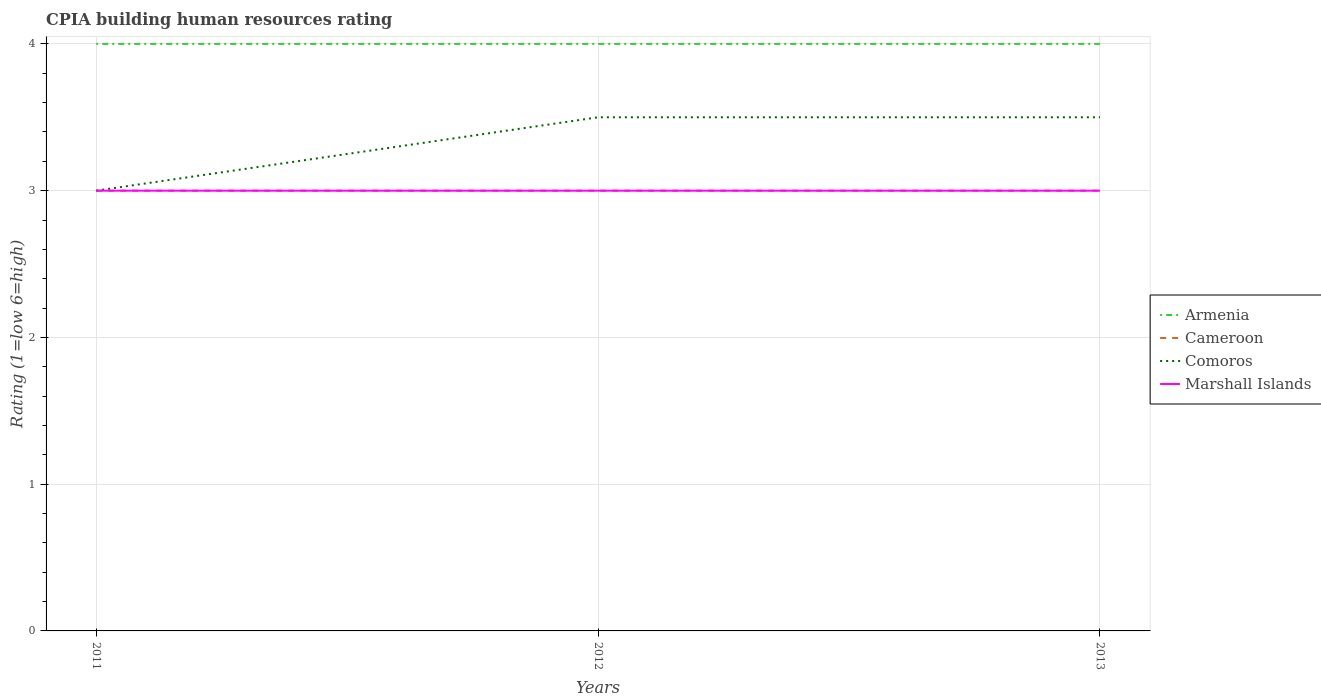Is the number of lines equal to the number of legend labels?
Your response must be concise. Yes. Across all years, what is the maximum CPIA rating in Marshall Islands?
Your answer should be very brief. 3. In which year was the CPIA rating in Comoros maximum?
Provide a short and direct response. 2011. What is the difference between the highest and the lowest CPIA rating in Comoros?
Provide a succinct answer. 2. Is the CPIA rating in Comoros strictly greater than the CPIA rating in Cameroon over the years?
Your answer should be very brief. No. Does the graph contain any zero values?
Offer a terse response. No. Does the graph contain grids?
Provide a succinct answer. Yes. Where does the legend appear in the graph?
Your answer should be very brief. Center right. How are the legend labels stacked?
Make the answer very short. Vertical. What is the title of the graph?
Make the answer very short. CPIA building human resources rating. What is the label or title of the X-axis?
Give a very brief answer. Years. What is the label or title of the Y-axis?
Provide a succinct answer. Rating (1=low 6=high). What is the Rating (1=low 6=high) of Comoros in 2011?
Make the answer very short. 3. What is the Rating (1=low 6=high) in Marshall Islands in 2011?
Your answer should be compact. 3. What is the Rating (1=low 6=high) in Armenia in 2012?
Offer a terse response. 4. What is the Rating (1=low 6=high) in Cameroon in 2012?
Give a very brief answer. 3. Across all years, what is the minimum Rating (1=low 6=high) in Armenia?
Offer a very short reply. 4. What is the total Rating (1=low 6=high) in Armenia in the graph?
Provide a short and direct response. 12. What is the total Rating (1=low 6=high) in Cameroon in the graph?
Provide a succinct answer. 9. What is the total Rating (1=low 6=high) in Comoros in the graph?
Keep it short and to the point. 10. What is the difference between the Rating (1=low 6=high) of Marshall Islands in 2011 and that in 2012?
Provide a short and direct response. 0. What is the difference between the Rating (1=low 6=high) of Armenia in 2011 and that in 2013?
Give a very brief answer. 0. What is the difference between the Rating (1=low 6=high) of Cameroon in 2011 and that in 2013?
Make the answer very short. 0. What is the difference between the Rating (1=low 6=high) in Comoros in 2011 and that in 2013?
Provide a short and direct response. -0.5. What is the difference between the Rating (1=low 6=high) of Cameroon in 2012 and that in 2013?
Provide a short and direct response. 0. What is the difference between the Rating (1=low 6=high) of Comoros in 2012 and that in 2013?
Your response must be concise. 0. What is the difference between the Rating (1=low 6=high) in Cameroon in 2011 and the Rating (1=low 6=high) in Marshall Islands in 2012?
Give a very brief answer. 0. What is the difference between the Rating (1=low 6=high) in Armenia in 2011 and the Rating (1=low 6=high) in Comoros in 2013?
Ensure brevity in your answer.  0.5. What is the difference between the Rating (1=low 6=high) in Armenia in 2011 and the Rating (1=low 6=high) in Marshall Islands in 2013?
Provide a succinct answer. 1. What is the difference between the Rating (1=low 6=high) of Armenia in 2012 and the Rating (1=low 6=high) of Cameroon in 2013?
Provide a succinct answer. 1. What is the difference between the Rating (1=low 6=high) of Armenia in 2012 and the Rating (1=low 6=high) of Comoros in 2013?
Your answer should be compact. 0.5. What is the difference between the Rating (1=low 6=high) of Armenia in 2012 and the Rating (1=low 6=high) of Marshall Islands in 2013?
Ensure brevity in your answer.  1. What is the average Rating (1=low 6=high) of Armenia per year?
Your response must be concise. 4. What is the average Rating (1=low 6=high) in Comoros per year?
Provide a short and direct response. 3.33. In the year 2011, what is the difference between the Rating (1=low 6=high) of Cameroon and Rating (1=low 6=high) of Comoros?
Your answer should be compact. 0. In the year 2011, what is the difference between the Rating (1=low 6=high) in Comoros and Rating (1=low 6=high) in Marshall Islands?
Provide a short and direct response. 0. In the year 2012, what is the difference between the Rating (1=low 6=high) of Armenia and Rating (1=low 6=high) of Cameroon?
Make the answer very short. 1. In the year 2012, what is the difference between the Rating (1=low 6=high) in Armenia and Rating (1=low 6=high) in Comoros?
Your response must be concise. 0.5. In the year 2012, what is the difference between the Rating (1=low 6=high) in Armenia and Rating (1=low 6=high) in Marshall Islands?
Provide a short and direct response. 1. In the year 2013, what is the difference between the Rating (1=low 6=high) in Armenia and Rating (1=low 6=high) in Marshall Islands?
Your answer should be compact. 1. In the year 2013, what is the difference between the Rating (1=low 6=high) in Cameroon and Rating (1=low 6=high) in Comoros?
Give a very brief answer. -0.5. In the year 2013, what is the difference between the Rating (1=low 6=high) of Comoros and Rating (1=low 6=high) of Marshall Islands?
Provide a short and direct response. 0.5. What is the ratio of the Rating (1=low 6=high) in Cameroon in 2011 to that in 2012?
Provide a short and direct response. 1. What is the ratio of the Rating (1=low 6=high) of Marshall Islands in 2011 to that in 2012?
Ensure brevity in your answer.  1. What is the ratio of the Rating (1=low 6=high) of Cameroon in 2011 to that in 2013?
Keep it short and to the point. 1. What is the ratio of the Rating (1=low 6=high) of Comoros in 2011 to that in 2013?
Your answer should be very brief. 0.86. What is the ratio of the Rating (1=low 6=high) of Marshall Islands in 2011 to that in 2013?
Offer a very short reply. 1. What is the ratio of the Rating (1=low 6=high) of Marshall Islands in 2012 to that in 2013?
Your answer should be compact. 1. What is the difference between the highest and the second highest Rating (1=low 6=high) of Armenia?
Ensure brevity in your answer.  0. What is the difference between the highest and the lowest Rating (1=low 6=high) in Armenia?
Provide a succinct answer. 0. 